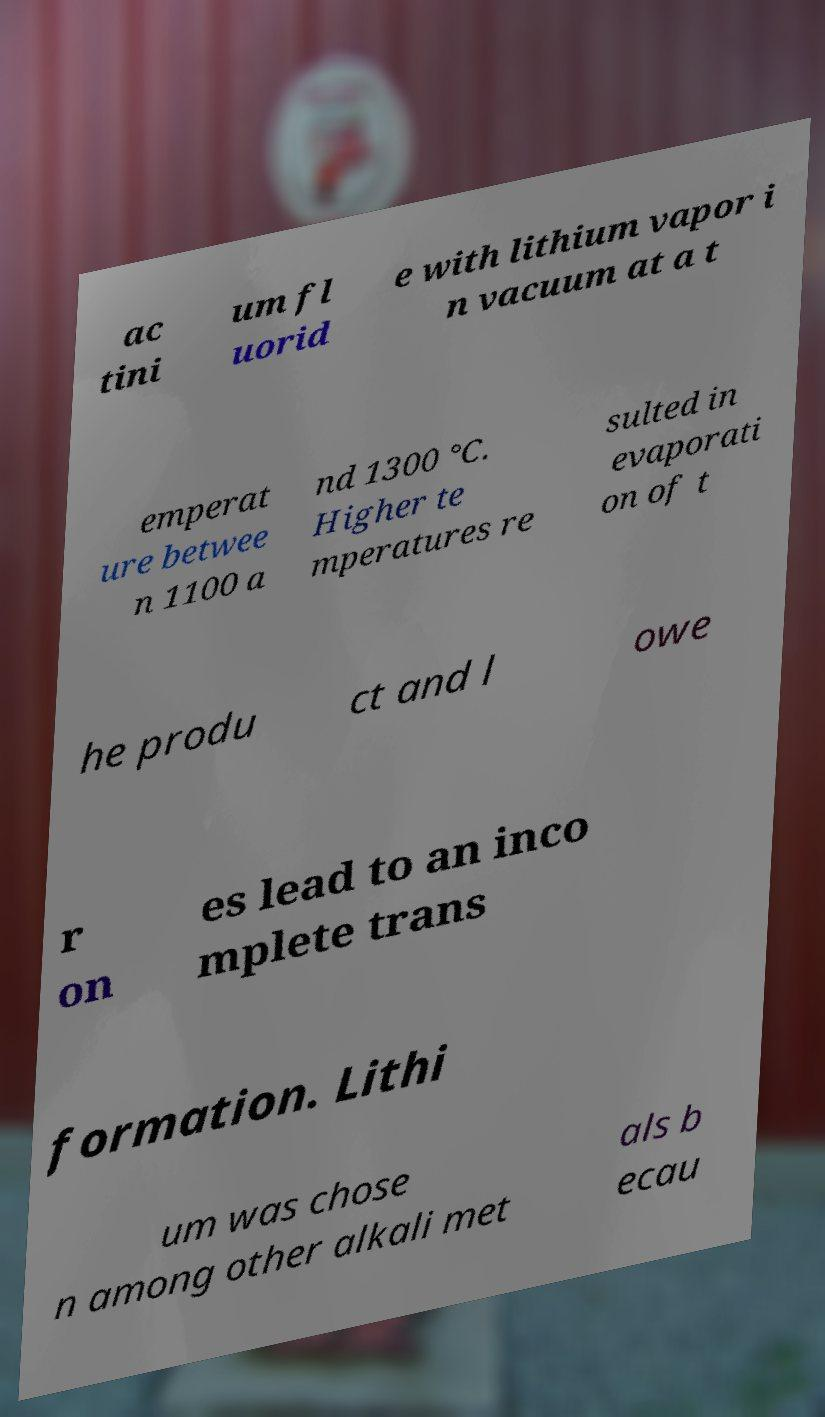Can you accurately transcribe the text from the provided image for me? ac tini um fl uorid e with lithium vapor i n vacuum at a t emperat ure betwee n 1100 a nd 1300 °C. Higher te mperatures re sulted in evaporati on of t he produ ct and l owe r on es lead to an inco mplete trans formation. Lithi um was chose n among other alkali met als b ecau 